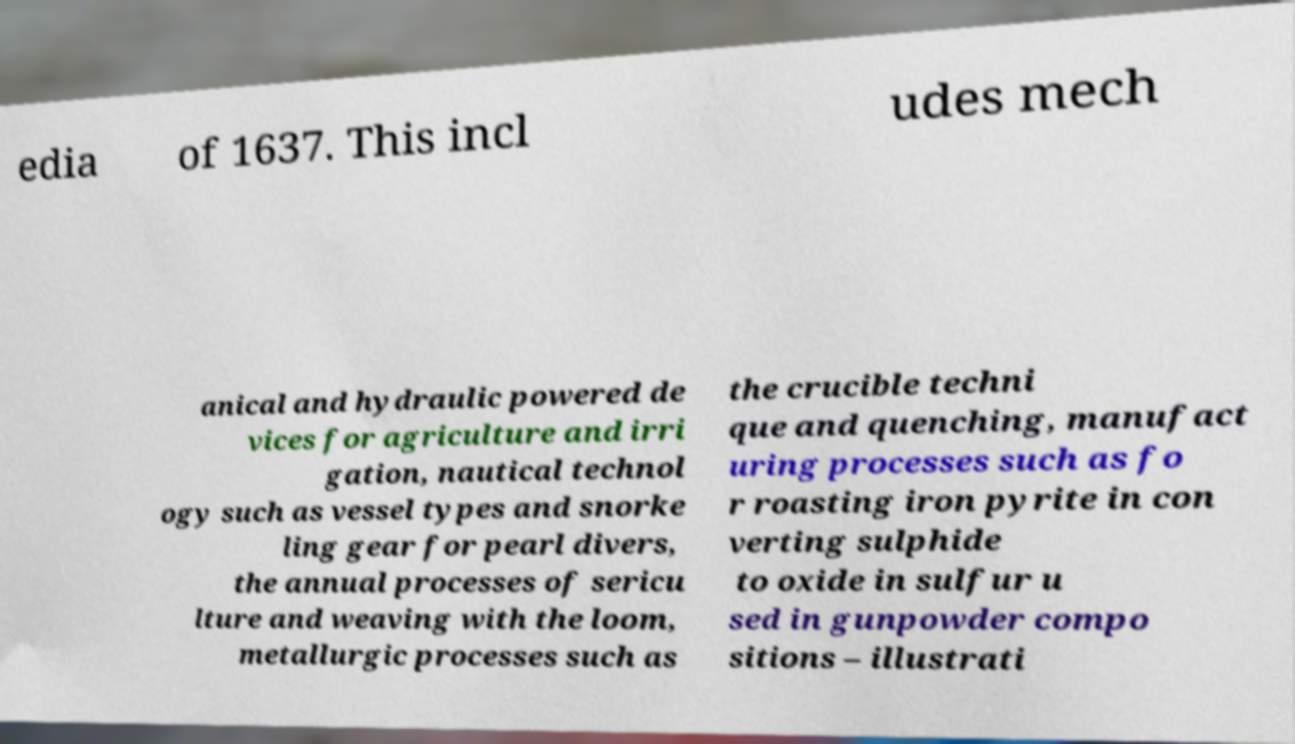Please identify and transcribe the text found in this image. edia of 1637. This incl udes mech anical and hydraulic powered de vices for agriculture and irri gation, nautical technol ogy such as vessel types and snorke ling gear for pearl divers, the annual processes of sericu lture and weaving with the loom, metallurgic processes such as the crucible techni que and quenching, manufact uring processes such as fo r roasting iron pyrite in con verting sulphide to oxide in sulfur u sed in gunpowder compo sitions – illustrati 